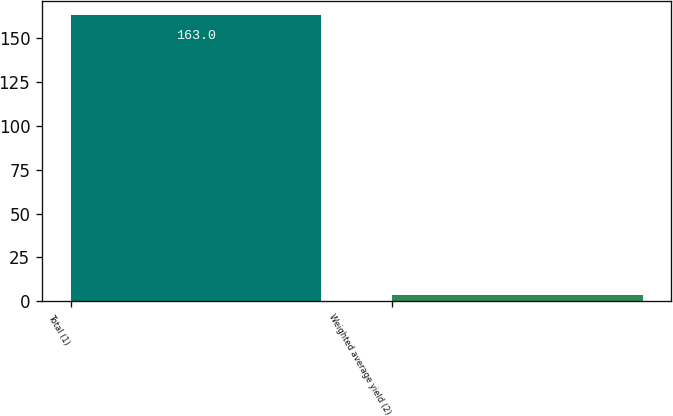Convert chart to OTSL. <chart><loc_0><loc_0><loc_500><loc_500><bar_chart><fcel>Total (1)<fcel>Weighted average yield (2)<nl><fcel>163<fcel>3.3<nl></chart> 